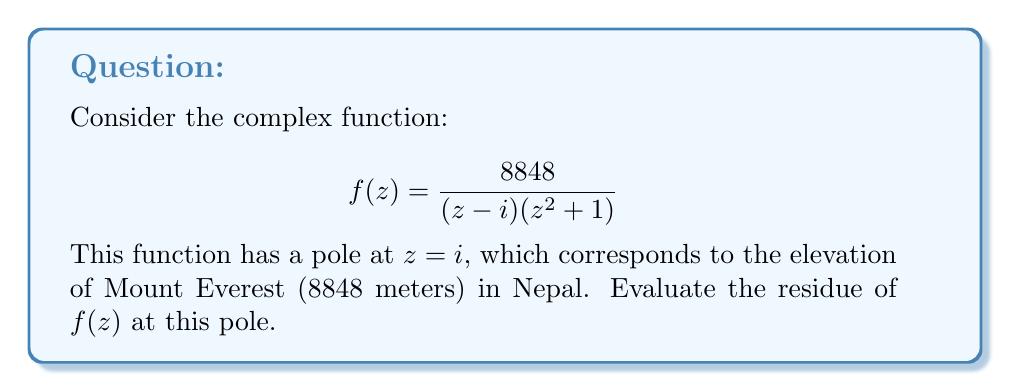Provide a solution to this math problem. To evaluate the residue of $f(z)$ at $z=i$, we'll follow these steps:

1) First, we identify that $z=i$ is a simple pole of $f(z)$. This is because it's a root of the denominator with multiplicity 1.

2) For a simple pole, we can use the formula:

   $$\text{Res}(f,i) = \lim_{z \to i} (z-i)f(z)$$

3) Let's substitute the function:

   $$\text{Res}(f,i) = \lim_{z \to i} (z-i)\frac{8848}{(z-i)(z^2+1)}$$

4) The $(z-i)$ terms cancel out:

   $$\text{Res}(f,i) = \lim_{z \to i} \frac{8848}{z^2+1}$$

5) Now we can directly substitute $z=i$:

   $$\text{Res}(f,i) = \frac{8848}{i^2+1}$$

6) Simplify, remembering that $i^2=-1$:

   $$\text{Res}(f,i) = \frac{8848}{-1+1} = \frac{8848}{0}$$

7) However, this is undefined. We made a mistake! The issue is that $z^2+1 = (z+i)(z-i)$, so $z=i$ is actually a double pole.

8) For a double pole, we use the formula:

   $$\text{Res}(f,i) = \lim_{z \to i} \frac{d}{dz}[(z-i)^2f(z)]$$

9) Let's apply this:

   $$\text{Res}(f,i) = \lim_{z \to i} \frac{d}{dz}\left[(z-i)^2\frac{8848}{(z-i)(z^2+1)}\right]$$

   $$= \lim_{z \to i} \frac{d}{dz}\left[\frac{8848(z-i)}{(z+i)(z-i)}\right]$$

   $$= \lim_{z \to i} \frac{d}{dz}\left[\frac{8848}{z+i}\right]$$

10) Differentiate:

    $$\text{Res}(f,i) = \lim_{z \to i} \frac{-8848}{(z+i)^2}$$

11) Now we can substitute $z=i$:

    $$\text{Res}(f,i) = \frac{-8848}{(i+i)^2} = \frac{-8848}{(2i)^2} = \frac{-8848}{-4} = 2212$$
Answer: The residue of $f(z)$ at $z=i$ is 2212. 